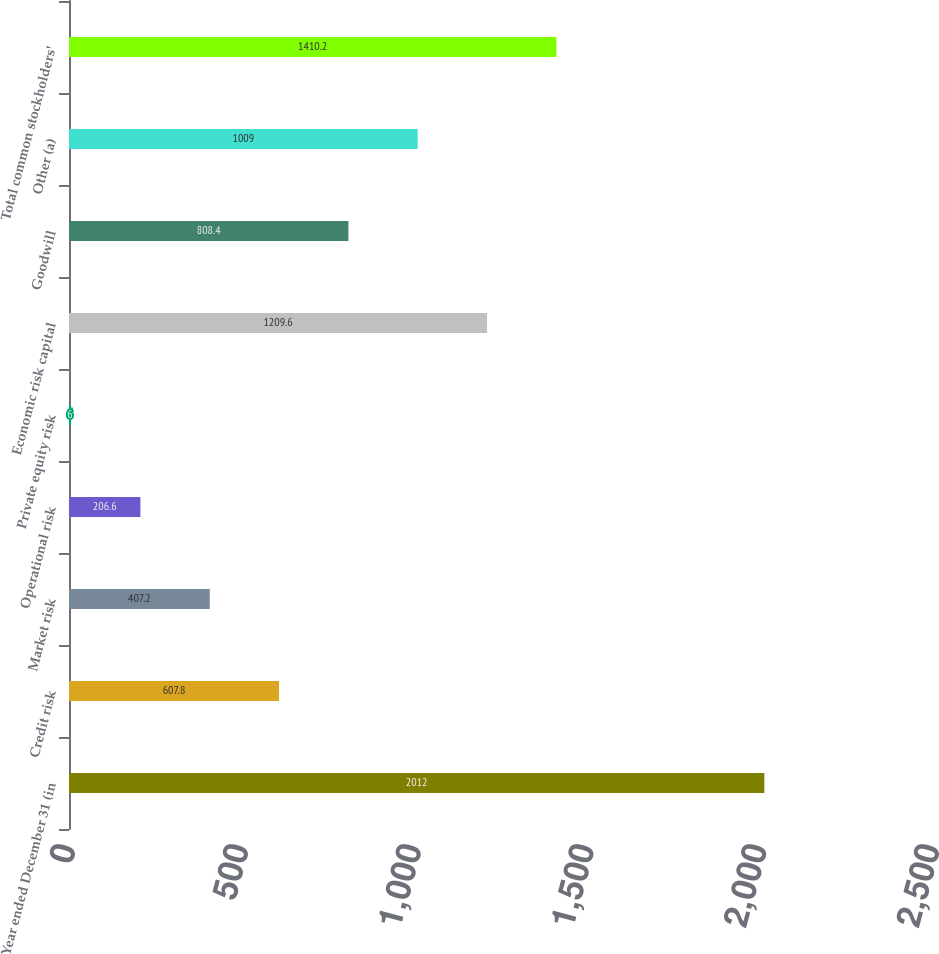Convert chart. <chart><loc_0><loc_0><loc_500><loc_500><bar_chart><fcel>Year ended December 31 (in<fcel>Credit risk<fcel>Market risk<fcel>Operational risk<fcel>Private equity risk<fcel>Economic risk capital<fcel>Goodwill<fcel>Other (a)<fcel>Total common stockholders'<nl><fcel>2012<fcel>607.8<fcel>407.2<fcel>206.6<fcel>6<fcel>1209.6<fcel>808.4<fcel>1009<fcel>1410.2<nl></chart> 